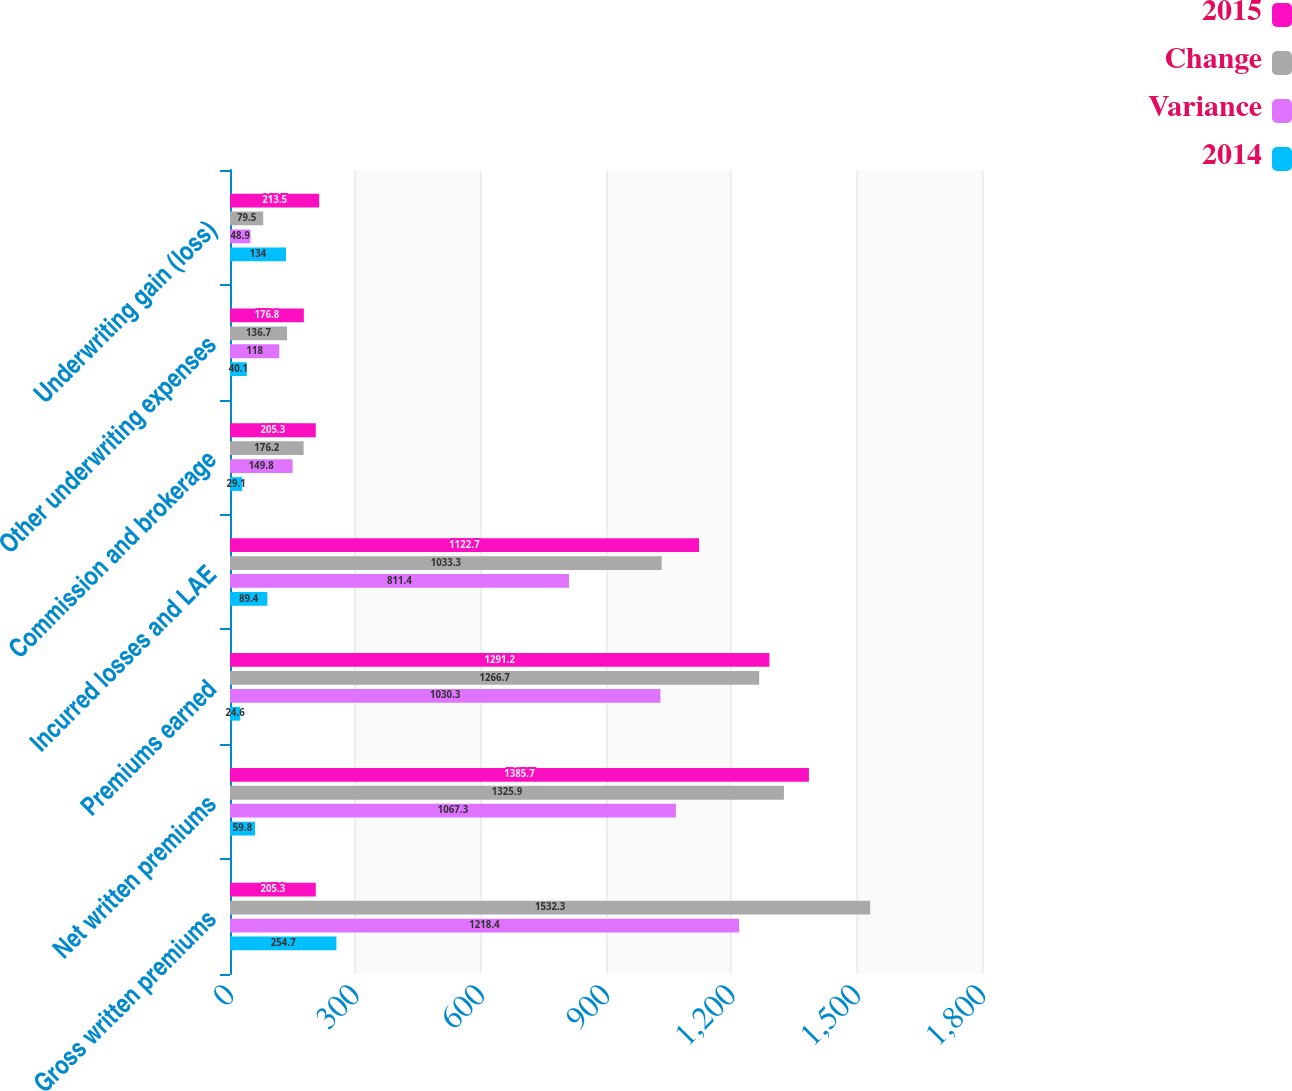Convert chart to OTSL. <chart><loc_0><loc_0><loc_500><loc_500><stacked_bar_chart><ecel><fcel>Gross written premiums<fcel>Net written premiums<fcel>Premiums earned<fcel>Incurred losses and LAE<fcel>Commission and brokerage<fcel>Other underwriting expenses<fcel>Underwriting gain (loss)<nl><fcel>2015<fcel>205.3<fcel>1385.7<fcel>1291.2<fcel>1122.7<fcel>205.3<fcel>176.8<fcel>213.5<nl><fcel>Change<fcel>1532.3<fcel>1325.9<fcel>1266.7<fcel>1033.3<fcel>176.2<fcel>136.7<fcel>79.5<nl><fcel>Variance<fcel>1218.4<fcel>1067.3<fcel>1030.3<fcel>811.4<fcel>149.8<fcel>118<fcel>48.9<nl><fcel>2014<fcel>254.7<fcel>59.8<fcel>24.6<fcel>89.4<fcel>29.1<fcel>40.1<fcel>134<nl></chart> 